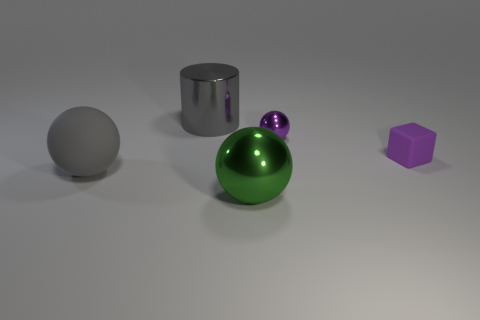Compared to the purple cube, how reflective is the green sphere? The green sphere has a high degree of reflectivity, much more than the matte surface of the purple cube. The sphere clearly reflects its surroundings, while the cube does not. 